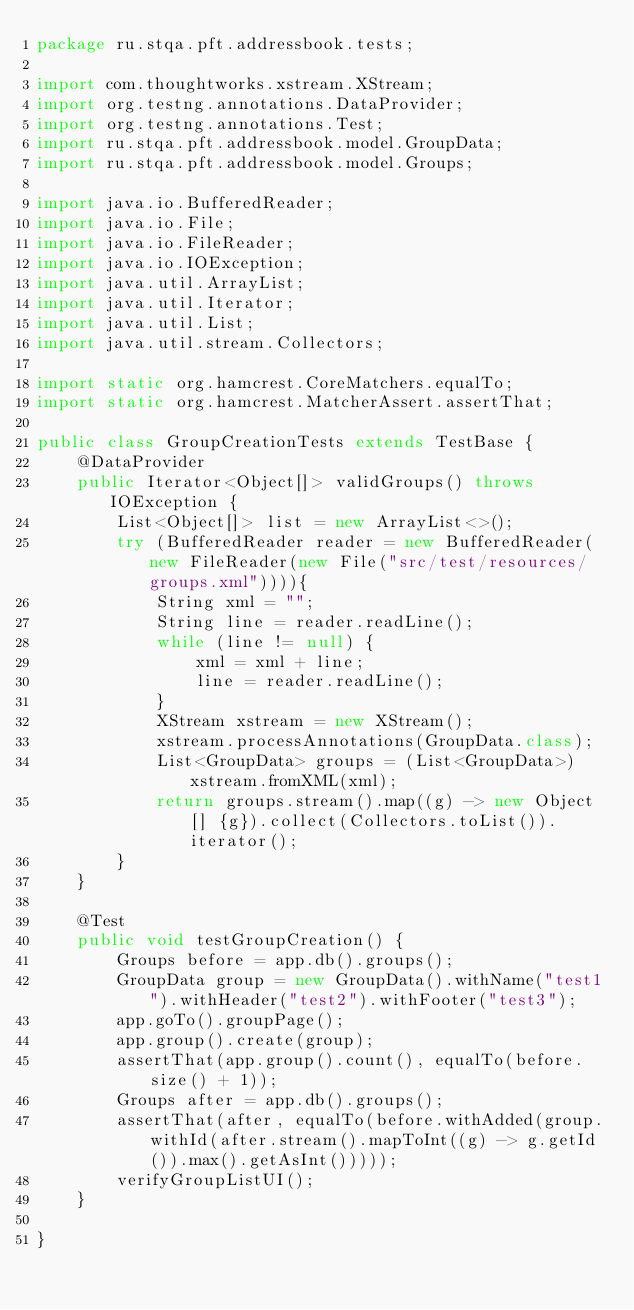Convert code to text. <code><loc_0><loc_0><loc_500><loc_500><_Java_>package ru.stqa.pft.addressbook.tests;

import com.thoughtworks.xstream.XStream;
import org.testng.annotations.DataProvider;
import org.testng.annotations.Test;
import ru.stqa.pft.addressbook.model.GroupData;
import ru.stqa.pft.addressbook.model.Groups;

import java.io.BufferedReader;
import java.io.File;
import java.io.FileReader;
import java.io.IOException;
import java.util.ArrayList;
import java.util.Iterator;
import java.util.List;
import java.util.stream.Collectors;

import static org.hamcrest.CoreMatchers.equalTo;
import static org.hamcrest.MatcherAssert.assertThat;

public class GroupCreationTests extends TestBase {
    @DataProvider
    public Iterator<Object[]> validGroups() throws IOException {
        List<Object[]> list = new ArrayList<>();
        try (BufferedReader reader = new BufferedReader(new FileReader(new File("src/test/resources/groups.xml")))){
            String xml = "";
            String line = reader.readLine();
            while (line != null) {
                xml = xml + line;
                line = reader.readLine();
            }
            XStream xstream = new XStream();
            xstream.processAnnotations(GroupData.class);
            List<GroupData> groups = (List<GroupData>) xstream.fromXML(xml);
            return groups.stream().map((g) -> new Object[] {g}).collect(Collectors.toList()).iterator();
        }
    }

    @Test
    public void testGroupCreation() {
        Groups before = app.db().groups();
        GroupData group = new GroupData().withName("test1").withHeader("test2").withFooter("test3");
        app.goTo().groupPage();
        app.group().create(group);
        assertThat(app.group().count(), equalTo(before.size() + 1));
        Groups after = app.db().groups();
        assertThat(after, equalTo(before.withAdded(group.withId(after.stream().mapToInt((g) -> g.getId()).max().getAsInt()))));
        verifyGroupListUI();
    }

}
</code> 